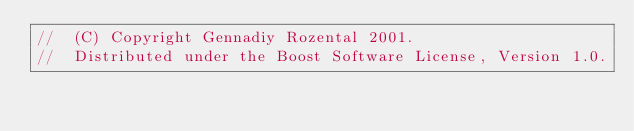<code> <loc_0><loc_0><loc_500><loc_500><_C++_>//  (C) Copyright Gennadiy Rozental 2001.
//  Distributed under the Boost Software License, Version 1.0.</code> 